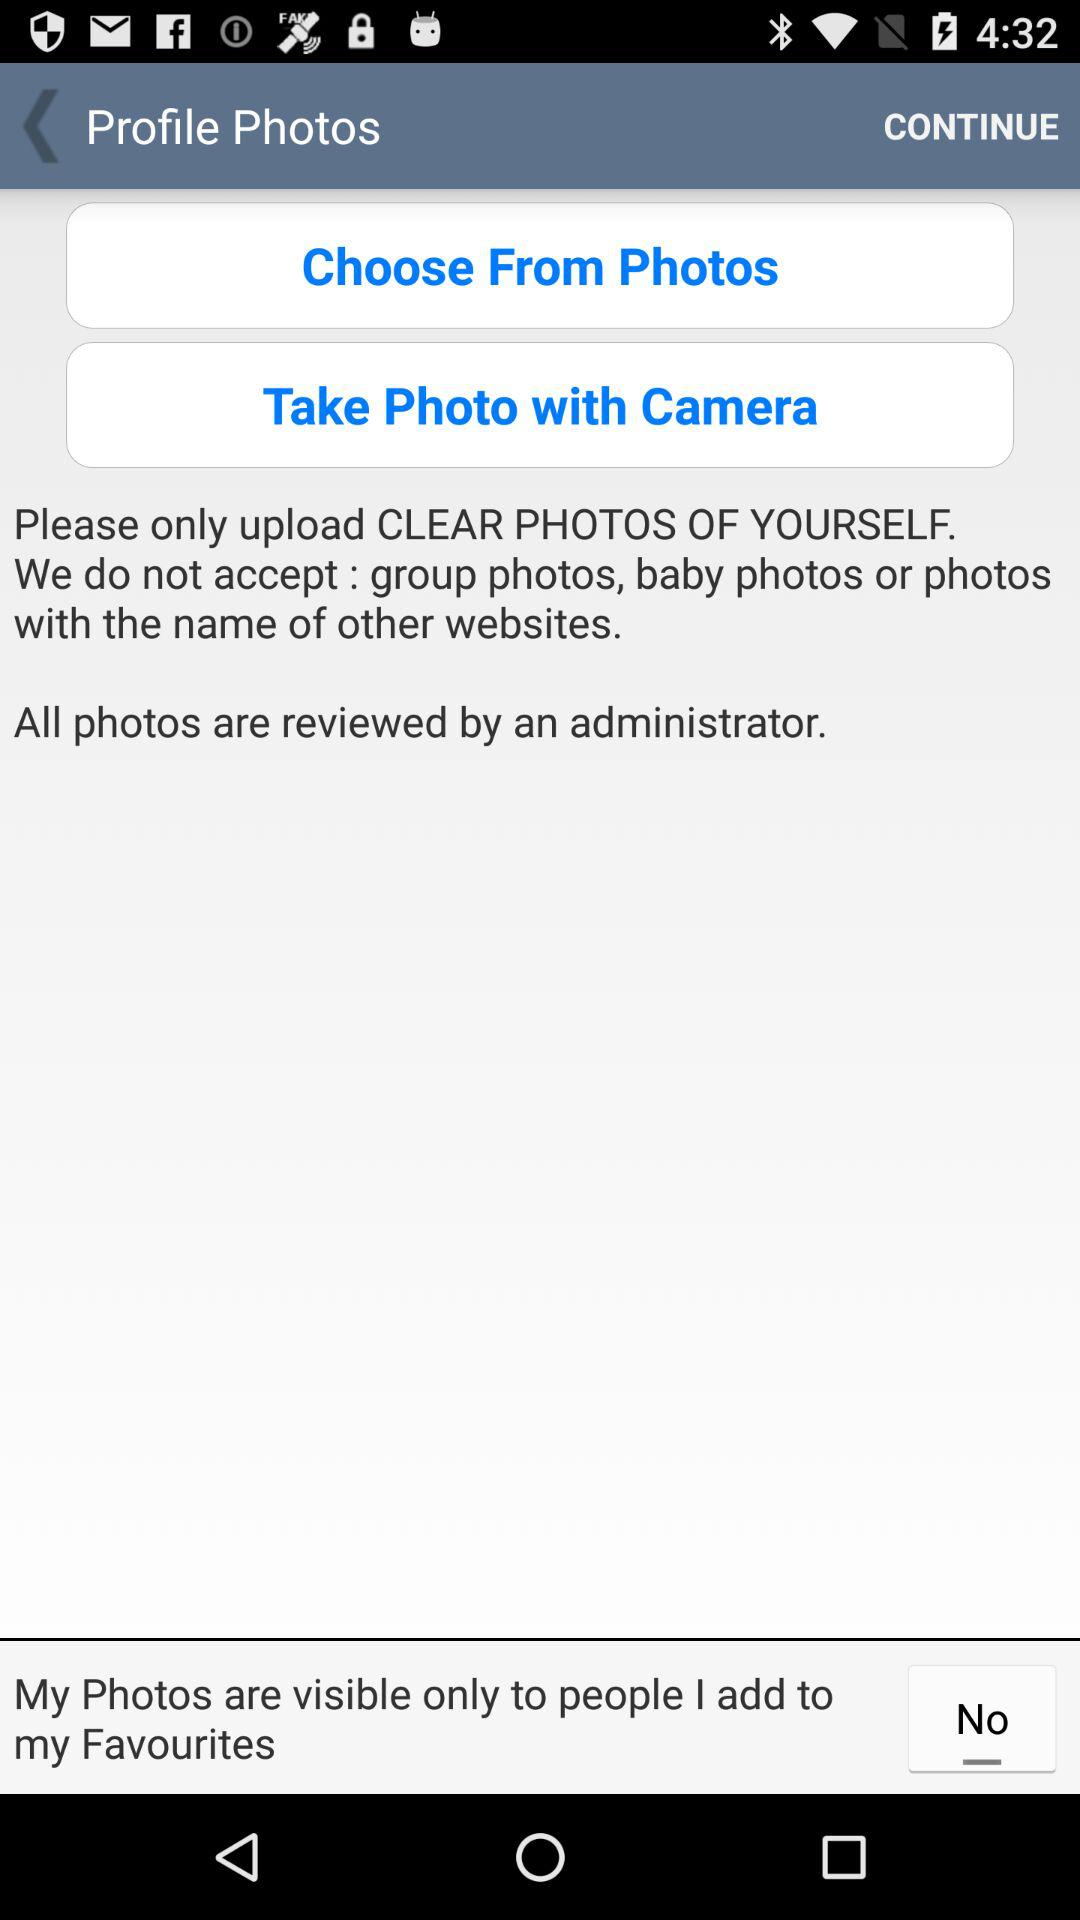What is the status of "My Photos are visible only to people I add to my Favourites"? The status is "No". 